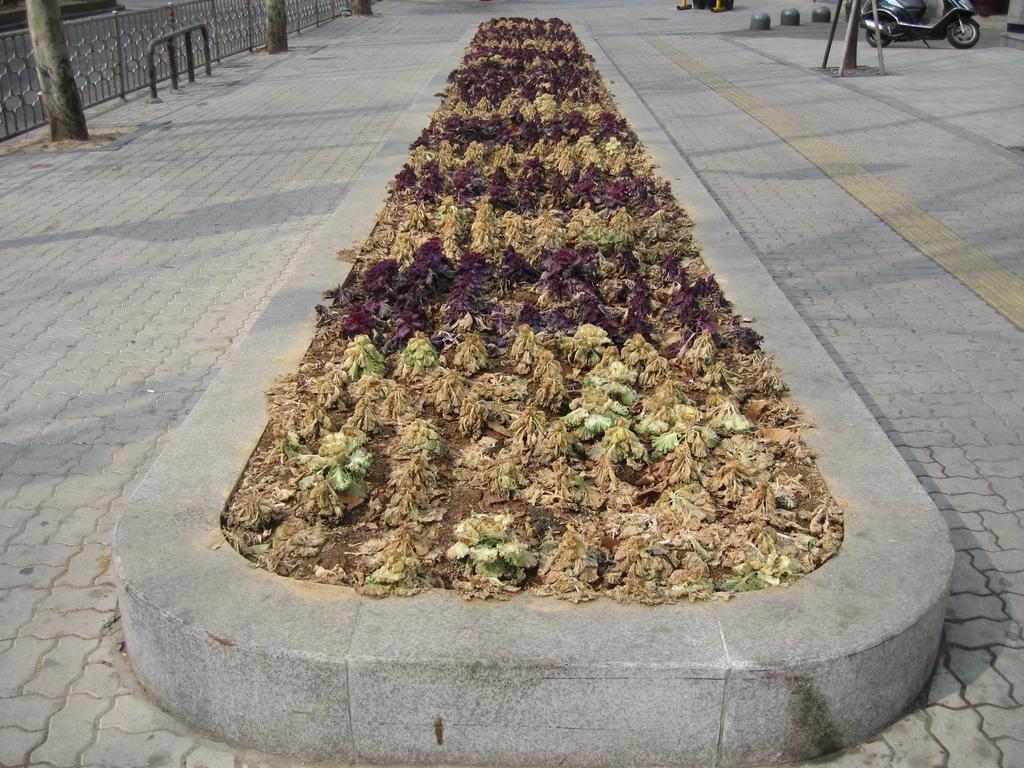Can you describe this image briefly? In this image there is a are so many plant in the middle of pavement, beside that there is a scooter parked on the road and on other side there is a fence and some trees parked in front of that. 